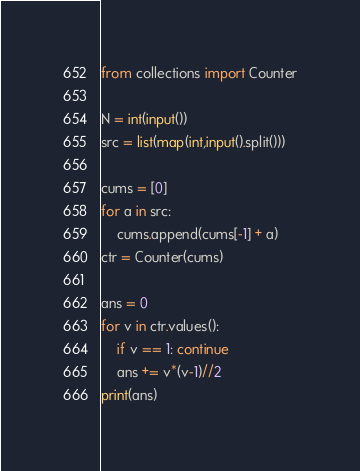Convert code to text. <code><loc_0><loc_0><loc_500><loc_500><_Python_>from collections import Counter

N = int(input())
src = list(map(int,input().split()))

cums = [0]
for a in src:
    cums.append(cums[-1] + a)
ctr = Counter(cums)

ans = 0
for v in ctr.values():
    if v == 1: continue
    ans += v*(v-1)//2
print(ans)
</code> 